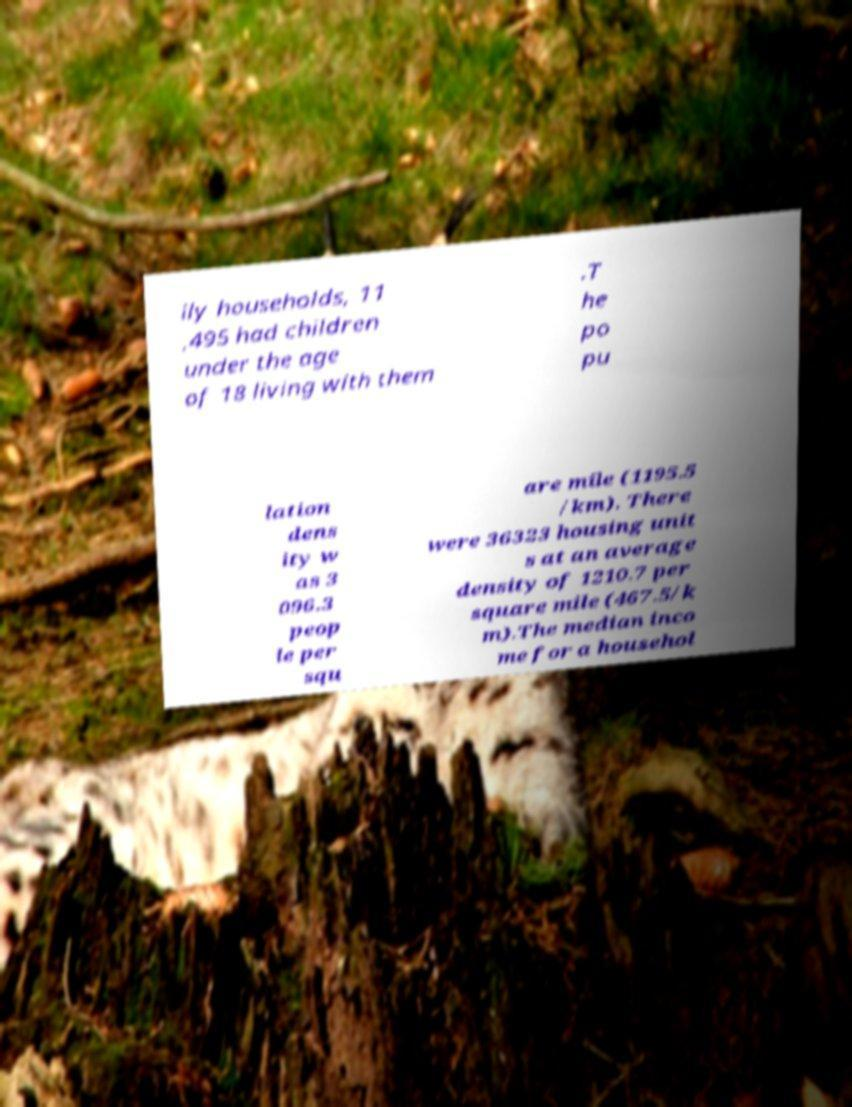For documentation purposes, I need the text within this image transcribed. Could you provide that? ily households, 11 ,495 had children under the age of 18 living with them .T he po pu lation dens ity w as 3 096.3 peop le per squ are mile (1195.5 /km). There were 36323 housing unit s at an average density of 1210.7 per square mile (467.5/k m).The median inco me for a househol 